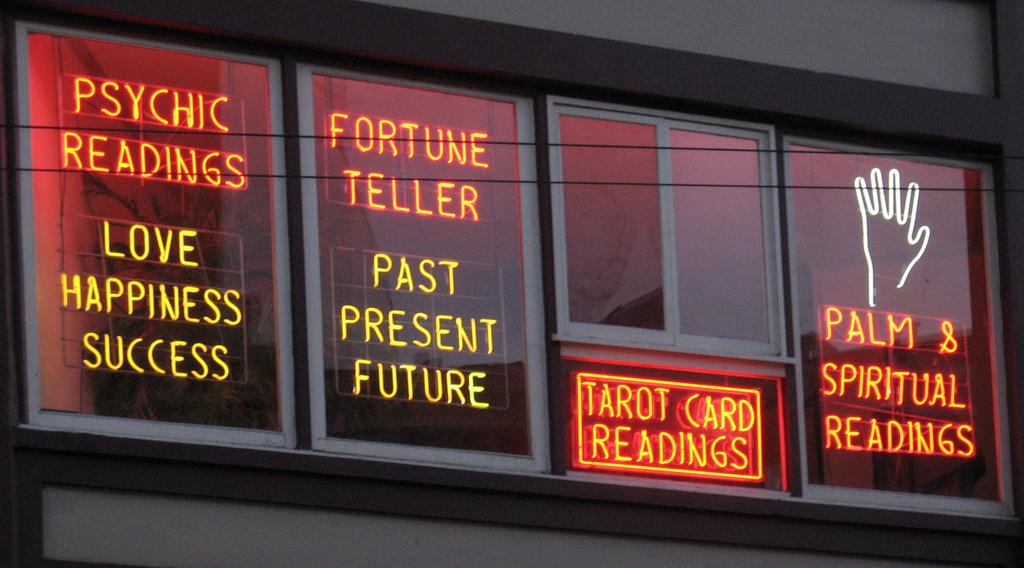Does the business have fortune tellers?
Offer a terse response. Yes. 